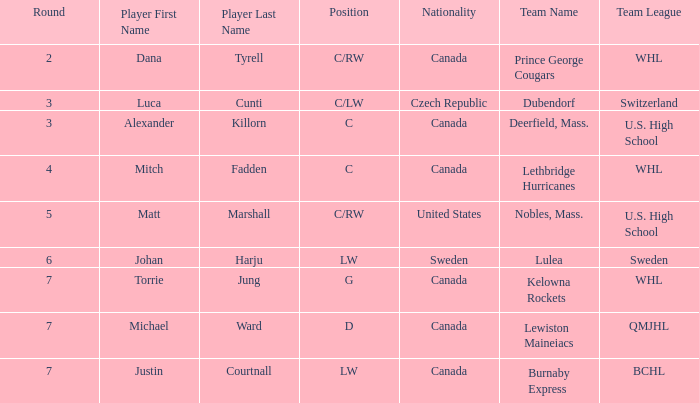What College/junior/club team (league) did mitch fadden play for? Lethbridge Hurricanes (WHL). 